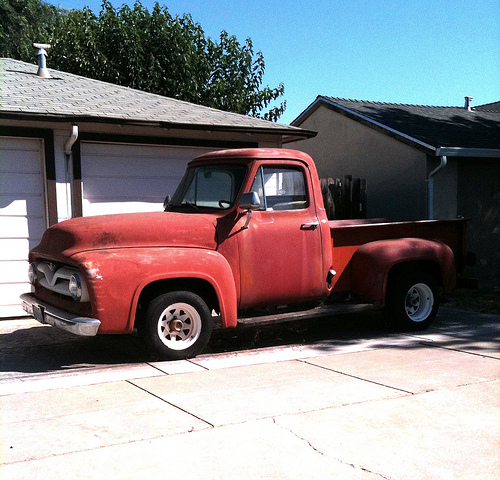<image>
Is there a building in front of the car? Yes. The building is positioned in front of the car, appearing closer to the camera viewpoint. Is there a roof above the truck? Yes. The roof is positioned above the truck in the vertical space, higher up in the scene. 